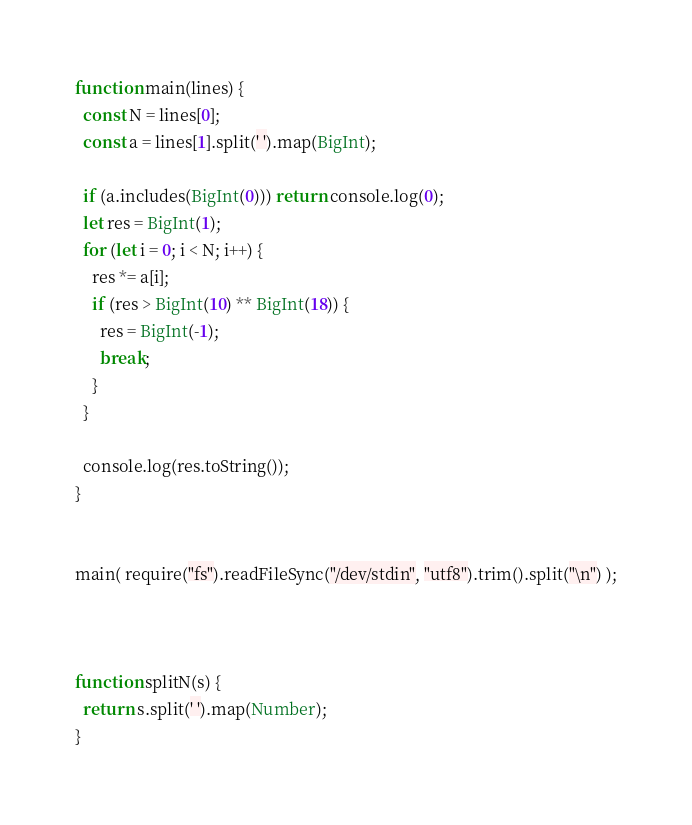<code> <loc_0><loc_0><loc_500><loc_500><_JavaScript_>function main(lines) {
  const N = lines[0];
  const a = lines[1].split(' ').map(BigInt);

  if (a.includes(BigInt(0))) return console.log(0);
  let res = BigInt(1);
  for (let i = 0; i < N; i++) {
    res *= a[i];
    if (res > BigInt(10) ** BigInt(18)) {
      res = BigInt(-1);
      break;
    }
  }

  console.log(res.toString());
}


main( require("fs").readFileSync("/dev/stdin", "utf8").trim().split("\n") );



function splitN(s) {
  return s.split(' ').map(Number);
}</code> 